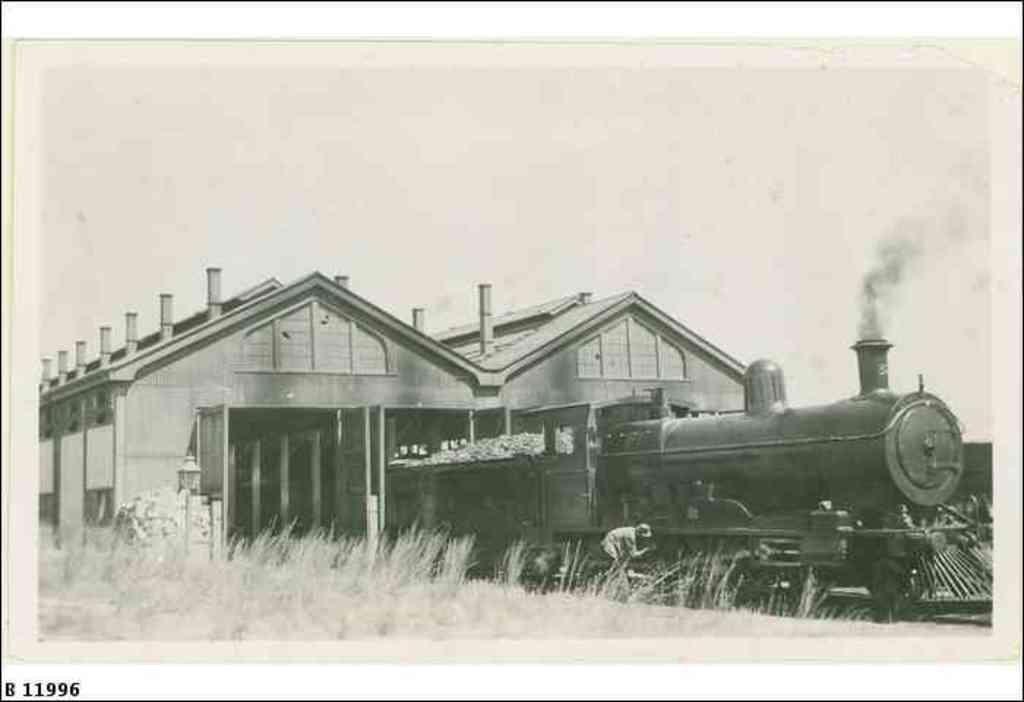In one or two sentences, can you explain what this image depicts? In this image we can see black and white picture of a train placed on the track. One person is standing. In the foreground we can see some plants. In the background, we can see buildings with poles and the sky. At the bottom we can see the sky. 